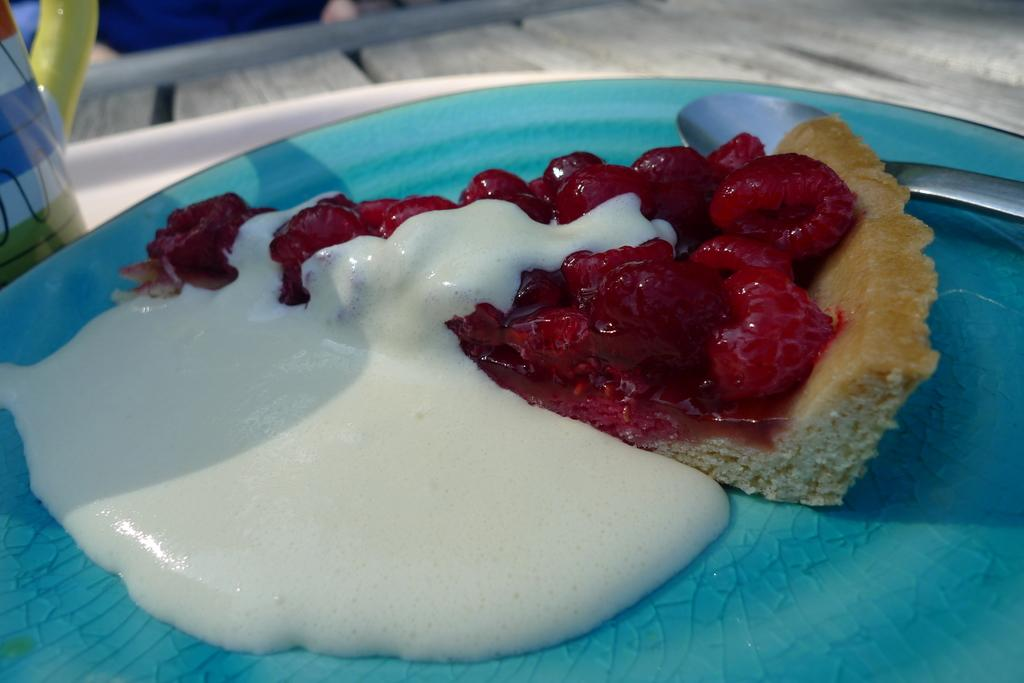What can be seen in the image related to food? There are food items in the image. What utensil is present in the image? There is a spoon in the image. What color is the plate that the spoon is on? The spoon is on a blue color plate. What is located on the left side of the image? There is a cup on the left side of the image. What type of surface can be seen in the background of the image? There is a wooden surface in the background of the image. What type of shoe is visible in the image? There is no shoe present in the image. What property is being sold in the image? There is no property being sold in the image; it features food items, a spoon, a cup, and a wooden surface. 